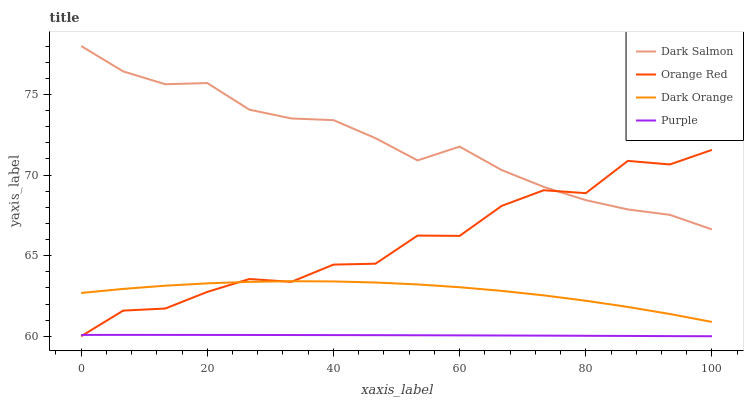Does Purple have the minimum area under the curve?
Answer yes or no. Yes. Does Dark Salmon have the maximum area under the curve?
Answer yes or no. Yes. Does Dark Orange have the minimum area under the curve?
Answer yes or no. No. Does Dark Orange have the maximum area under the curve?
Answer yes or no. No. Is Purple the smoothest?
Answer yes or no. Yes. Is Orange Red the roughest?
Answer yes or no. Yes. Is Dark Orange the smoothest?
Answer yes or no. No. Is Dark Orange the roughest?
Answer yes or no. No. Does Purple have the lowest value?
Answer yes or no. Yes. Does Dark Orange have the lowest value?
Answer yes or no. No. Does Dark Salmon have the highest value?
Answer yes or no. Yes. Does Dark Orange have the highest value?
Answer yes or no. No. Is Purple less than Dark Orange?
Answer yes or no. Yes. Is Dark Salmon greater than Purple?
Answer yes or no. Yes. Does Dark Salmon intersect Orange Red?
Answer yes or no. Yes. Is Dark Salmon less than Orange Red?
Answer yes or no. No. Is Dark Salmon greater than Orange Red?
Answer yes or no. No. Does Purple intersect Dark Orange?
Answer yes or no. No. 